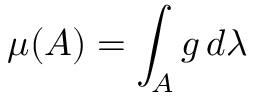<formula> <loc_0><loc_0><loc_500><loc_500>\mu ( A ) = \int _ { A } g \, d \lambda</formula> 